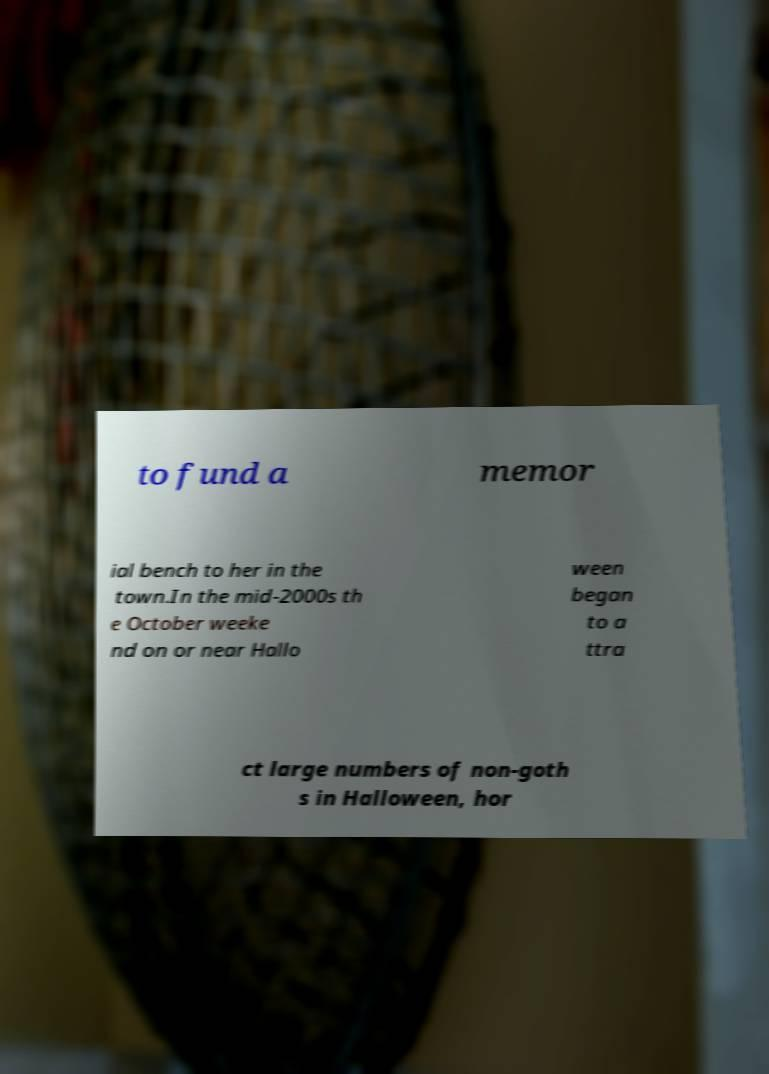Could you assist in decoding the text presented in this image and type it out clearly? to fund a memor ial bench to her in the town.In the mid-2000s th e October weeke nd on or near Hallo ween began to a ttra ct large numbers of non-goth s in Halloween, hor 